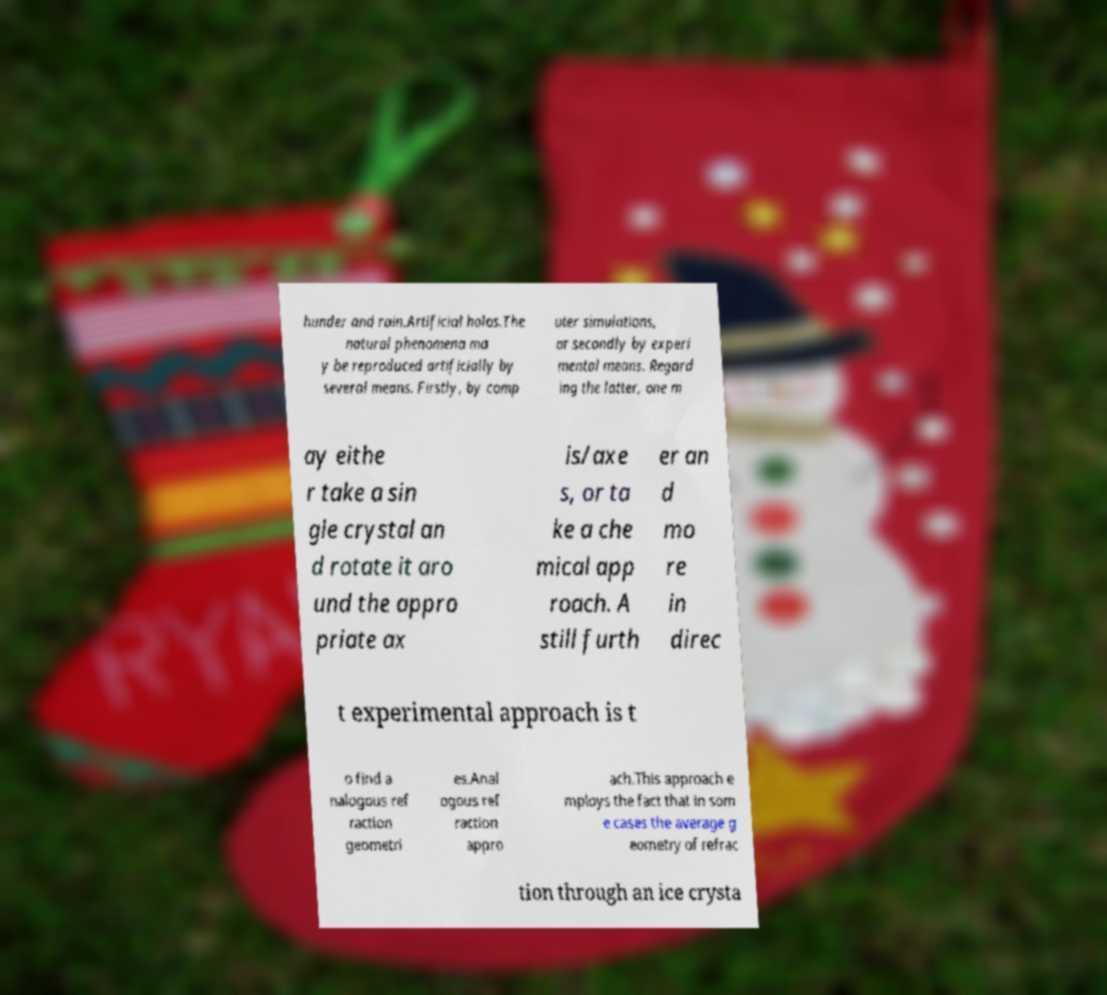I need the written content from this picture converted into text. Can you do that? hunder and rain.Artificial halos.The natural phenomena ma y be reproduced artificially by several means. Firstly, by comp uter simulations, or secondly by experi mental means. Regard ing the latter, one m ay eithe r take a sin gle crystal an d rotate it aro und the appro priate ax is/axe s, or ta ke a che mical app roach. A still furth er an d mo re in direc t experimental approach is t o find a nalogous ref raction geometri es.Anal ogous ref raction appro ach.This approach e mploys the fact that in som e cases the average g eometry of refrac tion through an ice crysta 